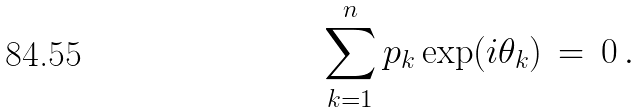Convert formula to latex. <formula><loc_0><loc_0><loc_500><loc_500>\sum _ { k = 1 } ^ { n } p _ { k } \exp ( i \theta _ { k } ) \, = \, 0 \, .</formula> 